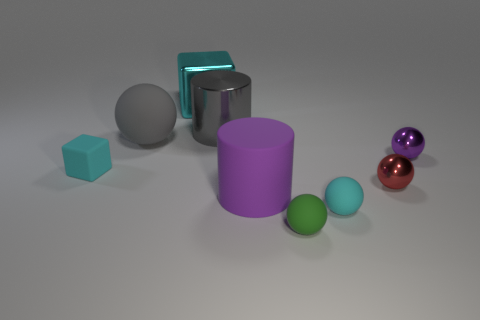Subtract all cyan balls. How many balls are left? 4 Subtract all green spheres. How many spheres are left? 4 Subtract all blue balls. Subtract all blue cubes. How many balls are left? 5 Subtract all cubes. How many objects are left? 7 Add 3 yellow spheres. How many yellow spheres exist? 3 Subtract 0 blue cylinders. How many objects are left? 9 Subtract all tiny blue cylinders. Subtract all purple objects. How many objects are left? 7 Add 5 big rubber things. How many big rubber things are left? 7 